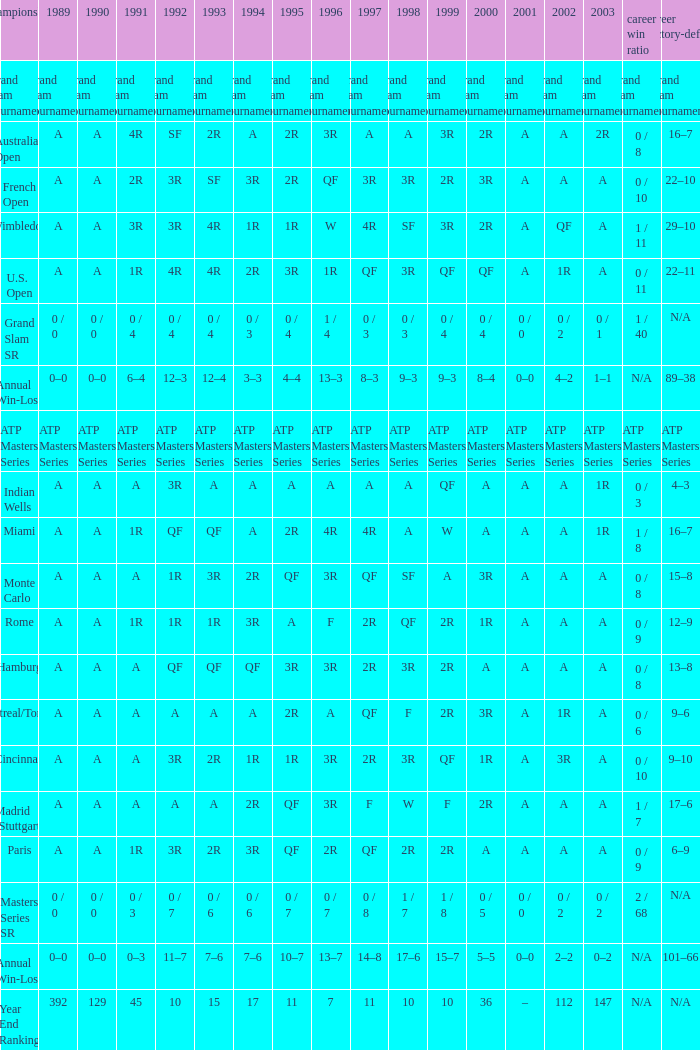What was the value in 1995 for A in 2000 at the Indian Wells tournament? A. 